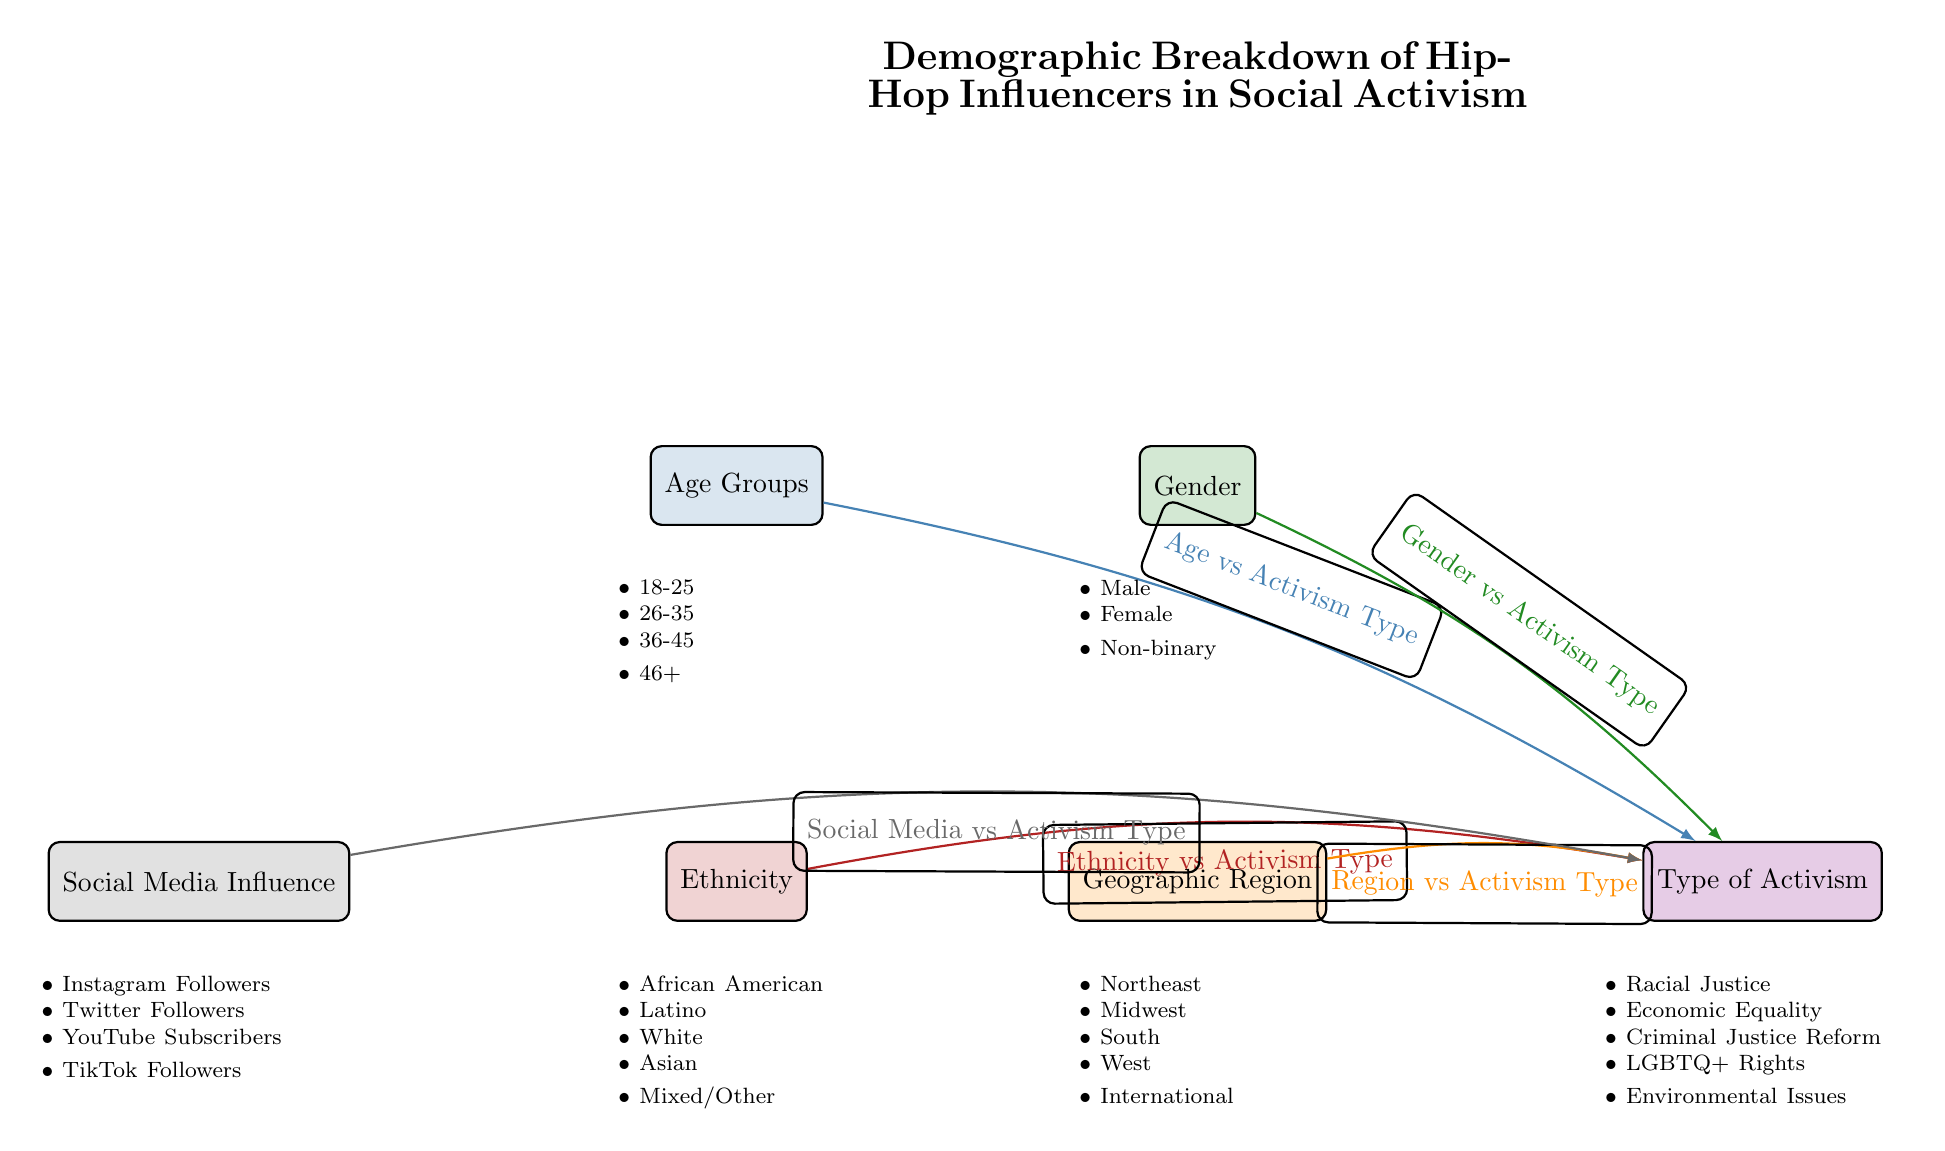What are the age groups represented in the diagram? The age groups listed in the diagram are found under the "Age Groups" node. They include: 18-25, 26-35, 36-45, and 46+.
Answer: 18-25, 26-35, 36-45, 46+ How many types of activism are mentioned? The "Type of Activism" node details five specific types: Racial Justice, Economic Equality, Criminal Justice Reform, LGBTQ+ Rights, and Environmental Issues. These can be counted to find the total.
Answer: 5 Which demographic influences activism the most based on the diagram's connections? The diagram connects "Age Groups", "Gender", "Ethnicity", "Geographic Region", and "Social Media Influence" to "Type of Activism". The type with the most connections isn't clearly indicated, but reasoning suggests that the highest social media influence may enhance activism.
Answer: Social Media Influence What is a relationship shown in the diagram? There is a direct relationship depicted by an edge between "Age Groups" and "Type of Activism", indicating that age influences the type of activism engaged in.
Answer: Age vs Activism Type Which demographic category is not directly linked to geographic region? Looking at the connections, "Age Groups" does not have a direct link to "Geographic Region", indicating that age is analyzed independently from regional factors concerning activism.
Answer: Age Groups 